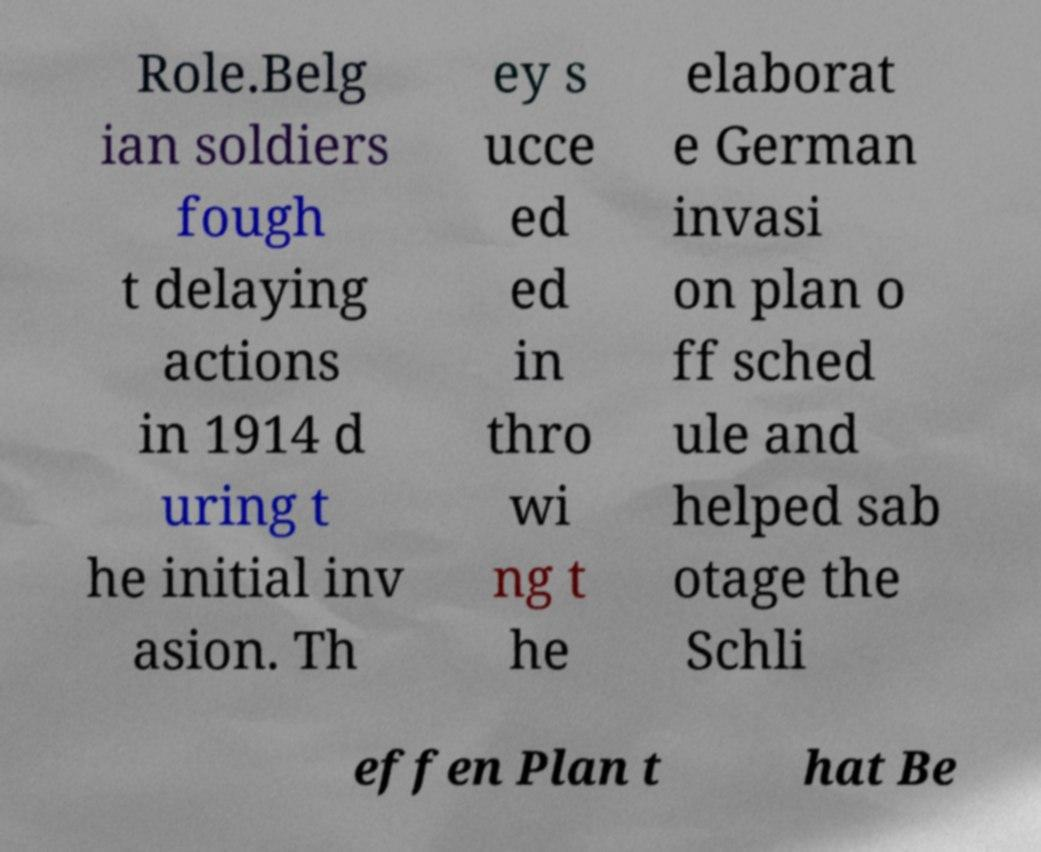There's text embedded in this image that I need extracted. Can you transcribe it verbatim? Role.Belg ian soldiers fough t delaying actions in 1914 d uring t he initial inv asion. Th ey s ucce ed ed in thro wi ng t he elaborat e German invasi on plan o ff sched ule and helped sab otage the Schli effen Plan t hat Be 